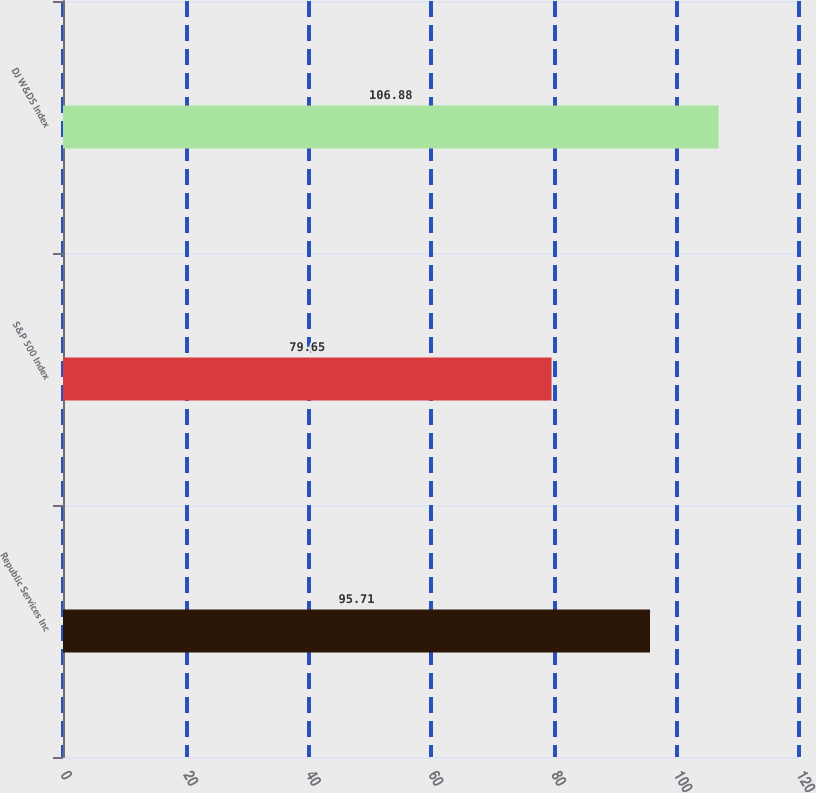Convert chart to OTSL. <chart><loc_0><loc_0><loc_500><loc_500><bar_chart><fcel>Republic Services Inc<fcel>S&P 500 Index<fcel>DJ W&DS Index<nl><fcel>95.71<fcel>79.65<fcel>106.88<nl></chart> 